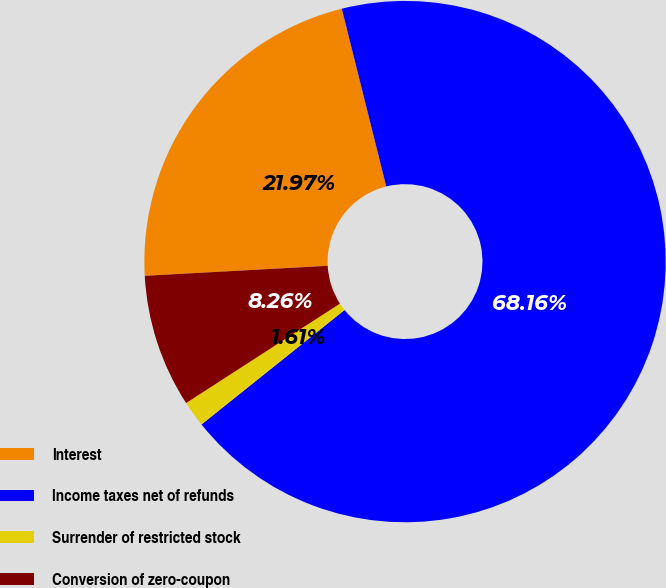Convert chart to OTSL. <chart><loc_0><loc_0><loc_500><loc_500><pie_chart><fcel>Interest<fcel>Income taxes net of refunds<fcel>Surrender of restricted stock<fcel>Conversion of zero-coupon<nl><fcel>21.97%<fcel>68.16%<fcel>1.61%<fcel>8.26%<nl></chart> 